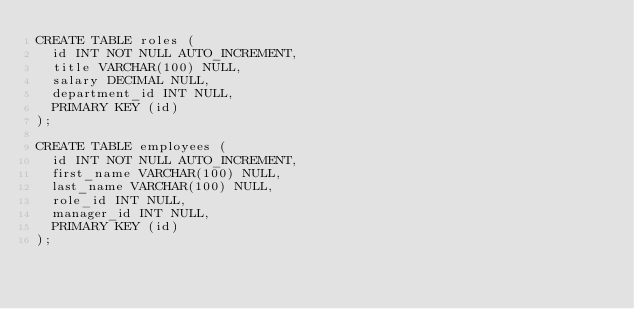<code> <loc_0><loc_0><loc_500><loc_500><_SQL_>CREATE TABLE roles (
  id INT NOT NULL AUTO_INCREMENT,
  title VARCHAR(100) NULL,
  salary DECIMAL NULL,
  department_id INT NULL,
  PRIMARY KEY (id)
);

CREATE TABLE employees (
  id INT NOT NULL AUTO_INCREMENT,
  first_name VARCHAR(100) NULL,
  last_name VARCHAR(100) NULL,
  role_id INT NULL,
  manager_id INT NULL,
  PRIMARY KEY (id)
);</code> 